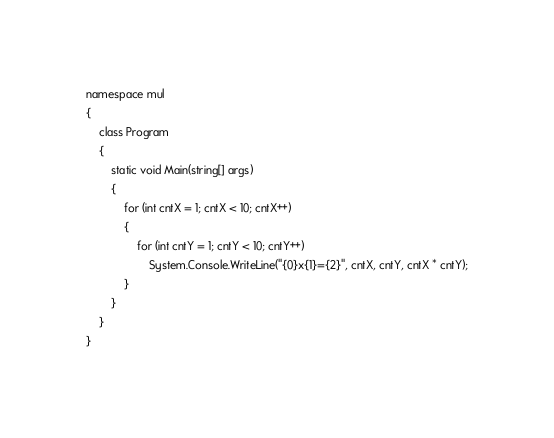Convert code to text. <code><loc_0><loc_0><loc_500><loc_500><_C#_>namespace mul
{
    class Program
    {
        static void Main(string[] args)
        {
            for (int cntX = 1; cntX < 10; cntX++)
            {
                for (int cntY = 1; cntY < 10; cntY++)
                    System.Console.WriteLine("{0}x{1}={2}", cntX, cntY, cntX * cntY);
            }
        }
    }
}</code> 